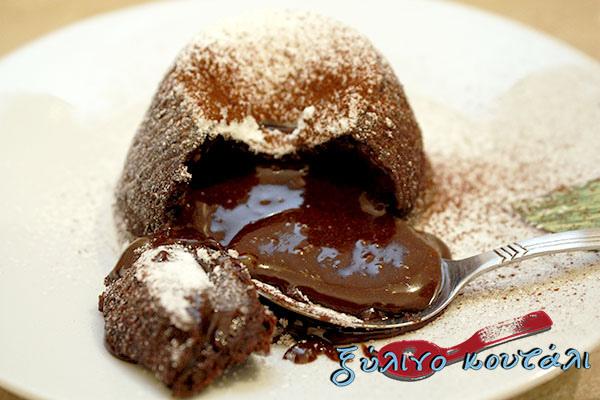What color is the plate?
Write a very short answer. White. What type of cake is this?
Quick response, please. Chocolate lava. Could you eat this if you are allergic to chocolate?
Short answer required. No. 